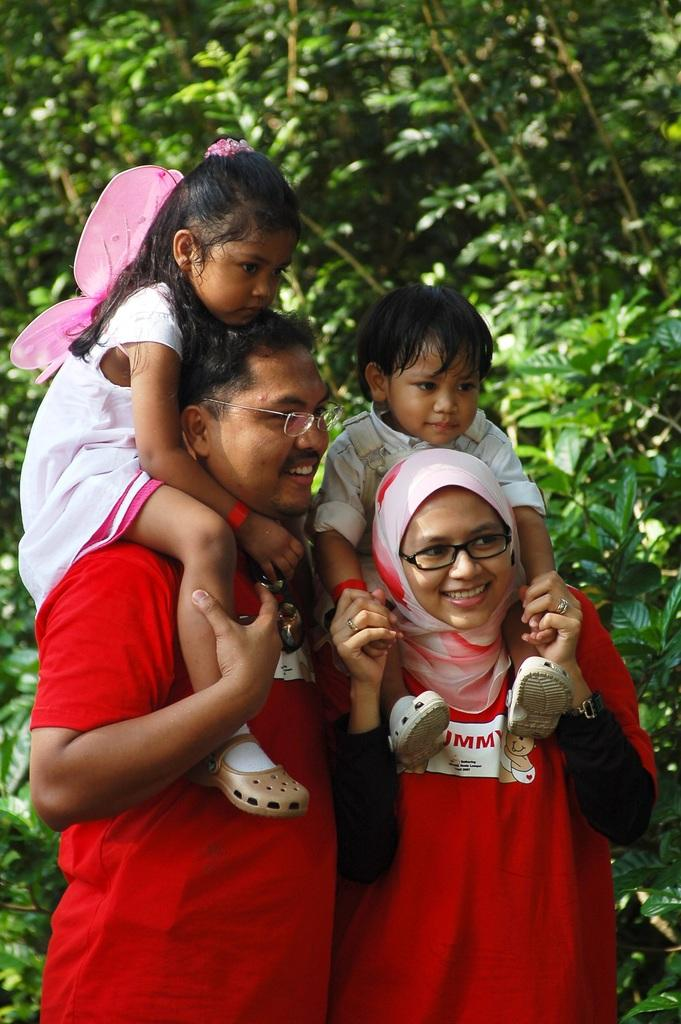What is located on the left side of the image? There is a man on the left side of the image. What is the man doing or holding in the image? There is a girl on the man. What is located on the right side of the image? There is a woman on the right side of the image. What is the woman doing or holding in the image? There is a child on the woman. What can be seen in the background of the image? There are plants and leaves in the background of the image. Is there any smoke coming from the man's mouth in the image? There is no smoke visible in the image. What type of hate is being expressed by the girl on the man? There is no indication of hate or any negative emotion in the image. 